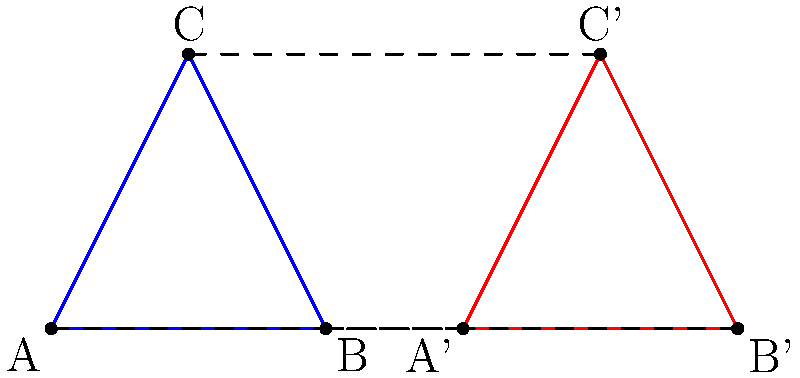In a digitally illustrated comic book action sequence, two triangles ABC and A'B'C' are shown as part of a character's movement. Which congruence transformation best describes the relationship between these triangles? To determine the congruence transformation between triangles ABC and A'B'C', let's analyze their properties step-by-step:

1. Shape and size: Both triangles appear to have the same shape and size, indicating they are congruent.

2. Orientation: The triangles have the same orientation, ruling out a reflection.

3. Position: Triangle A'B'C' is to the right of triangle ABC.

4. Corresponding points: 
   A maps to A'
   B maps to B'
   C maps to C'

5. Distance between corresponding points:
   The distance between A and A' is equal to the distance between B and B', and also equal to the distance between C and C'.

6. Direction of movement: All points move in the same direction (to the right) by the same distance.

Given these observations, we can conclude that triangle A'B'C' is the result of a translation of triangle ABC. The translation moves each point of the original triangle by the same distance in the same direction (to the right).

This type of transformation is common in comic book action sequences to show character movement or progression of action across panels.
Answer: Translation 